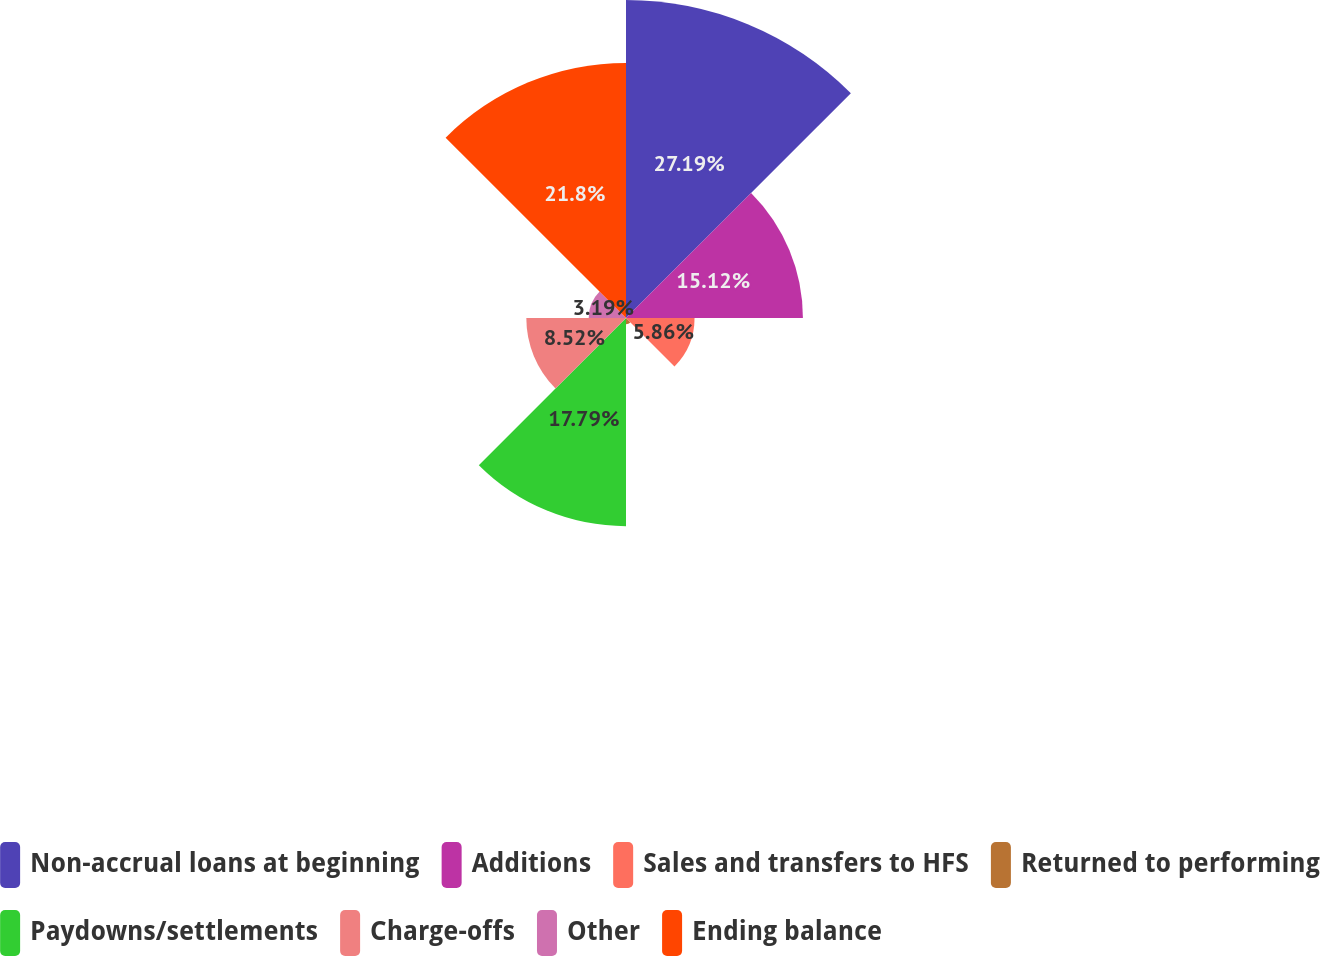<chart> <loc_0><loc_0><loc_500><loc_500><pie_chart><fcel>Non-accrual loans at beginning<fcel>Additions<fcel>Sales and transfers to HFS<fcel>Returned to performing<fcel>Paydowns/settlements<fcel>Charge-offs<fcel>Other<fcel>Ending balance<nl><fcel>27.18%<fcel>15.12%<fcel>5.86%<fcel>0.53%<fcel>17.79%<fcel>8.52%<fcel>3.19%<fcel>21.8%<nl></chart> 